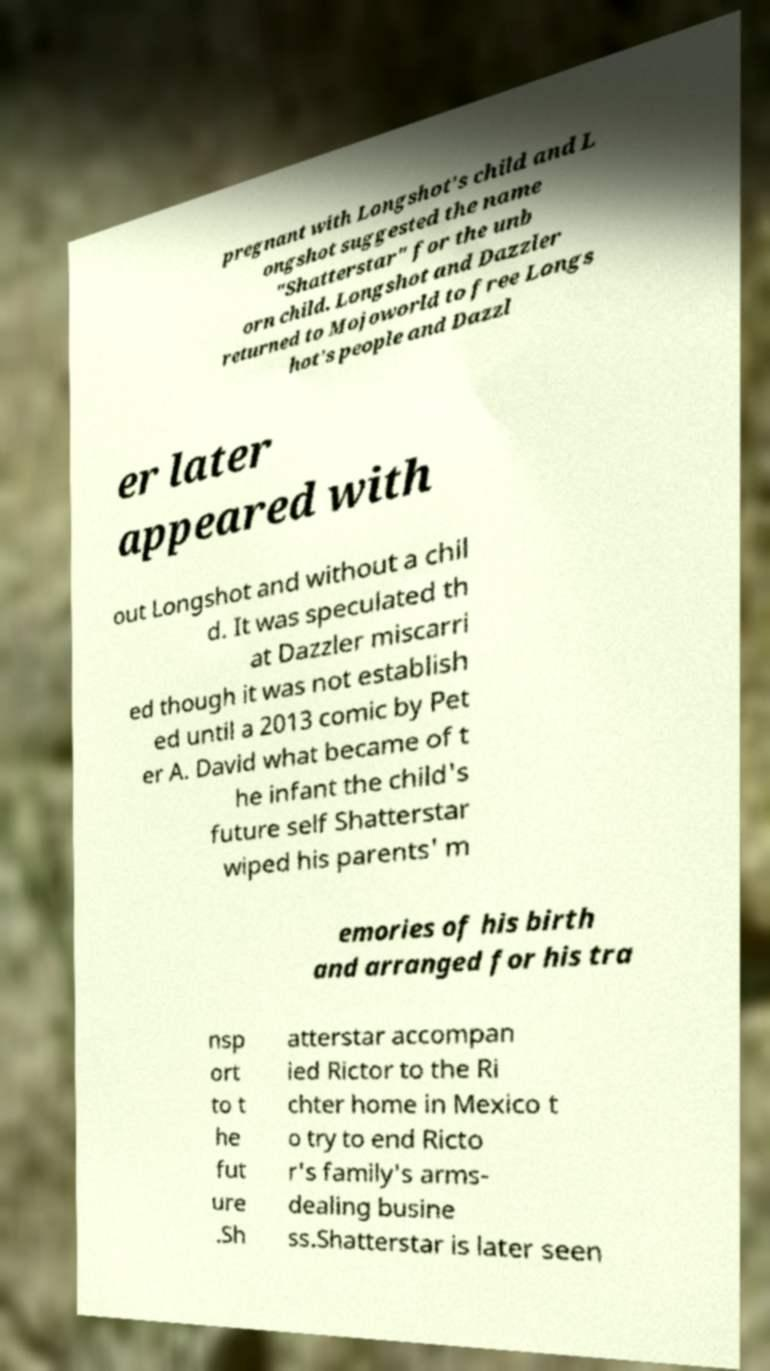For documentation purposes, I need the text within this image transcribed. Could you provide that? pregnant with Longshot's child and L ongshot suggested the name "Shatterstar" for the unb orn child. Longshot and Dazzler returned to Mojoworld to free Longs hot's people and Dazzl er later appeared with out Longshot and without a chil d. It was speculated th at Dazzler miscarri ed though it was not establish ed until a 2013 comic by Pet er A. David what became of t he infant the child's future self Shatterstar wiped his parents' m emories of his birth and arranged for his tra nsp ort to t he fut ure .Sh atterstar accompan ied Rictor to the Ri chter home in Mexico t o try to end Ricto r's family's arms- dealing busine ss.Shatterstar is later seen 